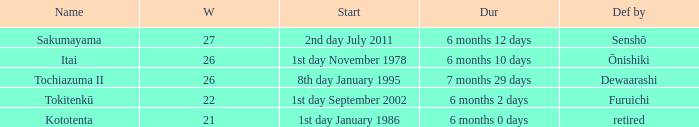Which Start has a Duration of 6 months 2 days? 1st day September 2002. 